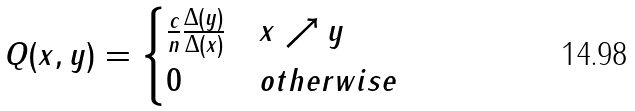Convert formula to latex. <formula><loc_0><loc_0><loc_500><loc_500>Q ( x , y ) = \begin{cases} \frac { c } { n } \frac { \Delta ( y ) } { \Delta ( x ) } & x \nearrow y \\ 0 & o t h e r w i s e \end{cases}</formula> 